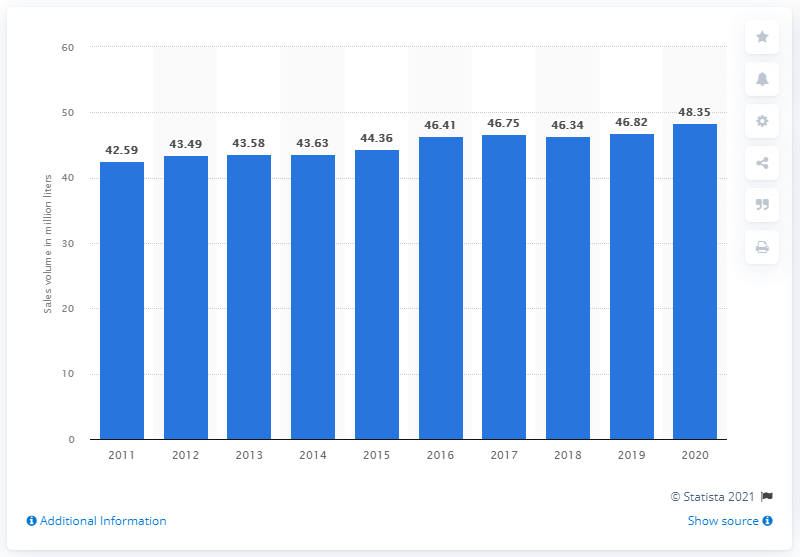Give some essential details in this illustration. In the fiscal year ending March 31, 2020, the volume of whisky sales in Canada was 48.35. In Canada, the sales volume of whisky from the previous year was 46.82.. 